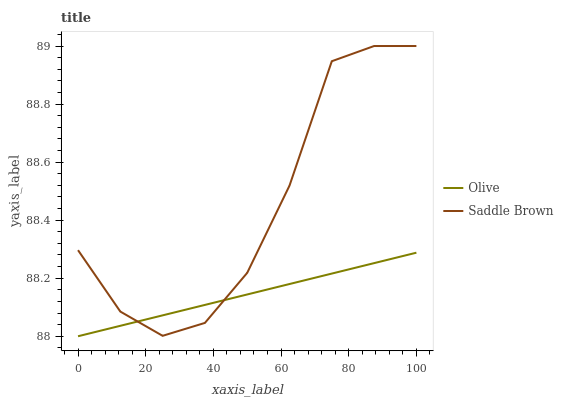Does Olive have the minimum area under the curve?
Answer yes or no. Yes. Does Saddle Brown have the maximum area under the curve?
Answer yes or no. Yes. Does Saddle Brown have the minimum area under the curve?
Answer yes or no. No. Is Olive the smoothest?
Answer yes or no. Yes. Is Saddle Brown the roughest?
Answer yes or no. Yes. Is Saddle Brown the smoothest?
Answer yes or no. No. Does Saddle Brown have the lowest value?
Answer yes or no. No. Does Saddle Brown have the highest value?
Answer yes or no. Yes. Does Saddle Brown intersect Olive?
Answer yes or no. Yes. Is Saddle Brown less than Olive?
Answer yes or no. No. Is Saddle Brown greater than Olive?
Answer yes or no. No. 